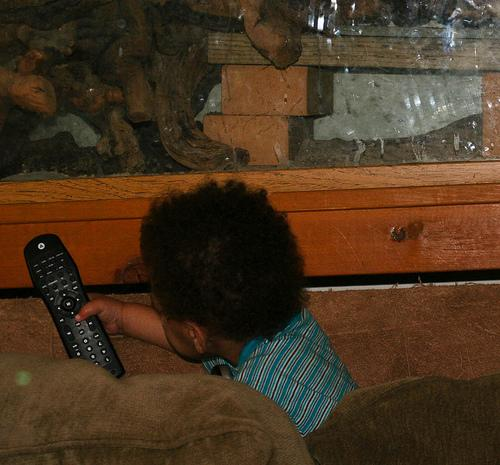What is the glass container likely to be? aquarium 